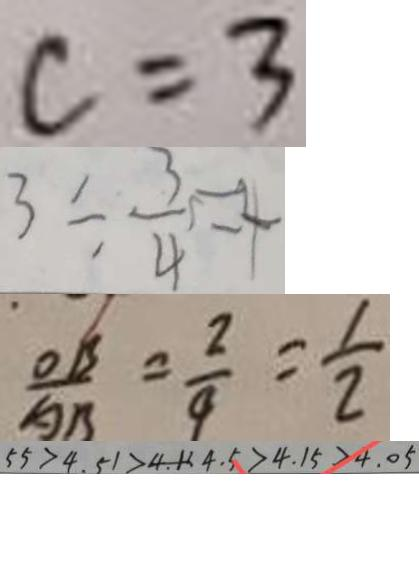Convert formula to latex. <formula><loc_0><loc_0><loc_500><loc_500>c = 3 
 3 \div \frac { 3 } { 4 } = 4 
 \frac { O B } { A B } = \frac { 2 } { 4 } = \frac { 1 } { 2 } 
 5 5 > 4 . 5 1 > 4 . 1 > 4 . 5 > 4 . 1 5 > 4 . 0 5</formula> 